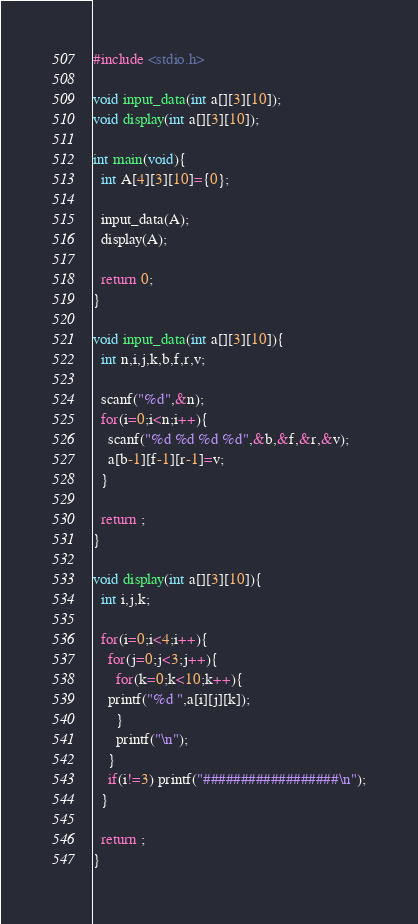<code> <loc_0><loc_0><loc_500><loc_500><_C_>#include <stdio.h>

void input_data(int a[][3][10]);
void display(int a[][3][10]);

int main(void){
  int A[4][3][10]={0};

  input_data(A);
  display(A);

  return 0;
}

void input_data(int a[][3][10]){
  int n,i,j,k,b,f,r,v;

  scanf("%d",&n);
  for(i=0;i<n;i++){
    scanf("%d %d %d %d",&b,&f,&r,&v);
    a[b-1][f-1][r-1]=v;
  }

  return ;
}

void display(int a[][3][10]){
  int i,j,k;

  for(i=0;i<4;i++){
    for(j=0;j<3;j++){
      for(k=0;k<10;k++){
	printf("%d ",a[i][j][k]);
      }
      printf("\n");
    }
    if(i!=3) printf("##################\n");
  }

  return ;
}</code> 